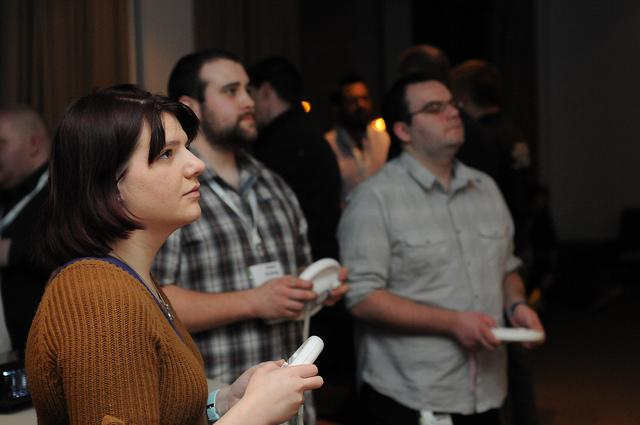What part of a car is symbolized in the objects they are holding? Please explain your reasoning. steering wheel. They are holding a circular controller that resembles the part of a car that drivers use to control the direction the car travels. 